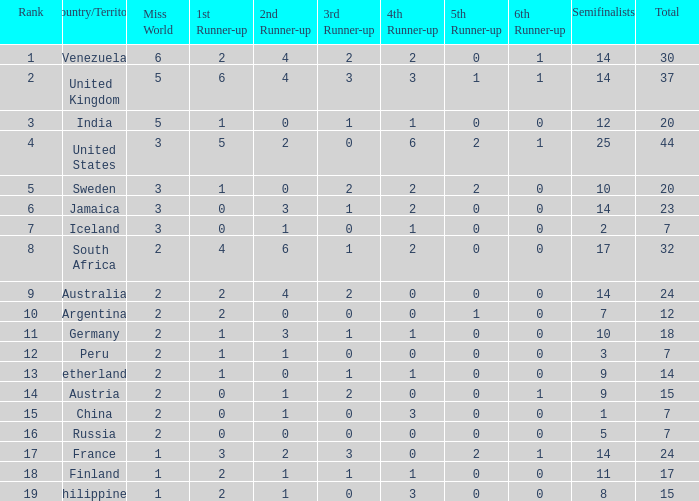What is Iceland's total? 1.0. 